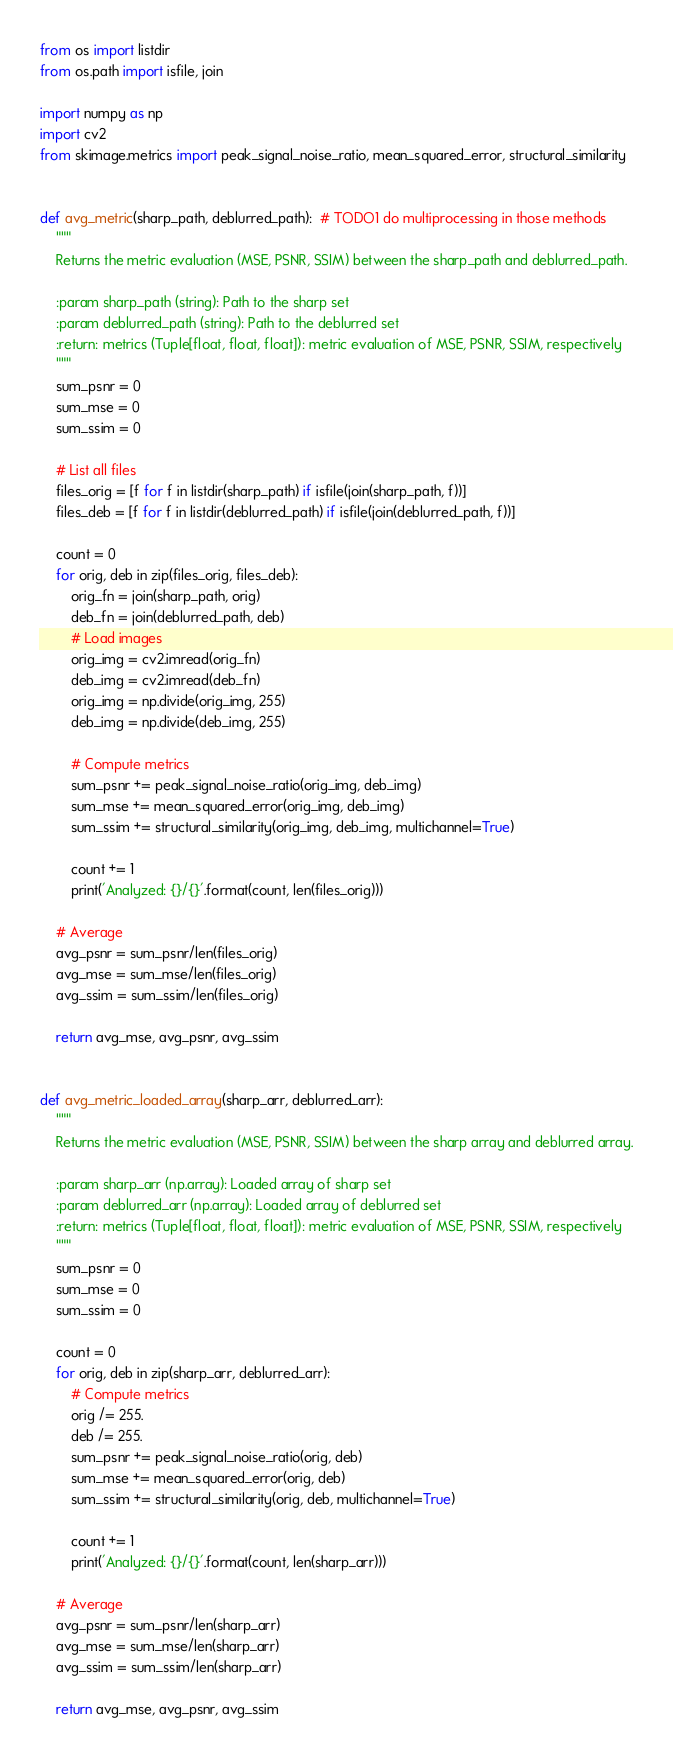Convert code to text. <code><loc_0><loc_0><loc_500><loc_500><_Python_>from os import listdir
from os.path import isfile, join

import numpy as np
import cv2
from skimage.metrics import peak_signal_noise_ratio, mean_squared_error, structural_similarity


def avg_metric(sharp_path, deblurred_path):  # TODO1 do multiprocessing in those methods
    """
    Returns the metric evaluation (MSE, PSNR, SSIM) between the sharp_path and deblurred_path.

    :param sharp_path (string): Path to the sharp set
    :param deblurred_path (string): Path to the deblurred set
    :return: metrics (Tuple[float, float, float]): metric evaluation of MSE, PSNR, SSIM, respectively
    """
    sum_psnr = 0
    sum_mse = 0
    sum_ssim = 0

    # List all files
    files_orig = [f for f in listdir(sharp_path) if isfile(join(sharp_path, f))]
    files_deb = [f for f in listdir(deblurred_path) if isfile(join(deblurred_path, f))]

    count = 0
    for orig, deb in zip(files_orig, files_deb):
        orig_fn = join(sharp_path, orig)
        deb_fn = join(deblurred_path, deb)
        # Load images
        orig_img = cv2.imread(orig_fn)
        deb_img = cv2.imread(deb_fn)
        orig_img = np.divide(orig_img, 255)
        deb_img = np.divide(deb_img, 255)

        # Compute metrics
        sum_psnr += peak_signal_noise_ratio(orig_img, deb_img)
        sum_mse += mean_squared_error(orig_img, deb_img)
        sum_ssim += structural_similarity(orig_img, deb_img, multichannel=True)

        count += 1
        print('Analyzed: {}/{}'.format(count, len(files_orig)))

    # Average
    avg_psnr = sum_psnr/len(files_orig)
    avg_mse = sum_mse/len(files_orig)
    avg_ssim = sum_ssim/len(files_orig)

    return avg_mse, avg_psnr, avg_ssim


def avg_metric_loaded_array(sharp_arr, deblurred_arr):
    """
    Returns the metric evaluation (MSE, PSNR, SSIM) between the sharp array and deblurred array.

    :param sharp_arr (np.array): Loaded array of sharp set
    :param deblurred_arr (np.array): Loaded array of deblurred set
    :return: metrics (Tuple[float, float, float]): metric evaluation of MSE, PSNR, SSIM, respectively
    """
    sum_psnr = 0
    sum_mse = 0
    sum_ssim = 0

    count = 0
    for orig, deb in zip(sharp_arr, deblurred_arr):
        # Compute metrics
        orig /= 255.
        deb /= 255.
        sum_psnr += peak_signal_noise_ratio(orig, deb)
        sum_mse += mean_squared_error(orig, deb)
        sum_ssim += structural_similarity(orig, deb, multichannel=True)

        count += 1
        print('Analyzed: {}/{}'.format(count, len(sharp_arr)))

    # Average
    avg_psnr = sum_psnr/len(sharp_arr)
    avg_mse = sum_mse/len(sharp_arr)
    avg_ssim = sum_ssim/len(sharp_arr)

    return avg_mse, avg_psnr, avg_ssim
</code> 